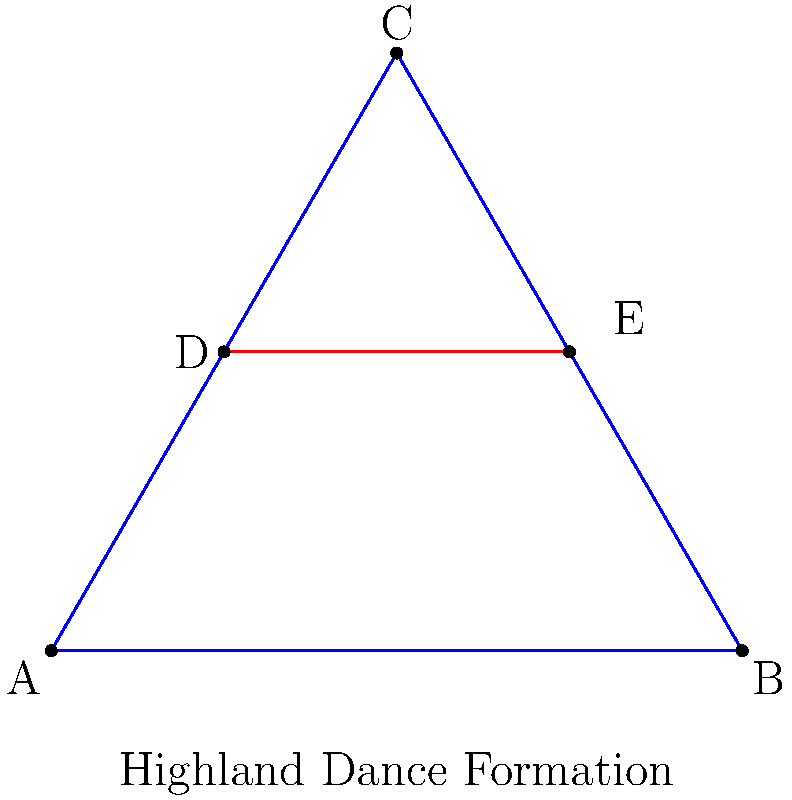In the Highland dance formation depicted above, dancers form an equilateral triangle ABC with a line segment DE connecting the midpoints of two sides. If the distance between dancers A and B is 8 feet, what is the length of DE in feet? Let's approach this step-by-step:

1) First, we recognize that ABC is an equilateral triangle, and DE is a line segment connecting the midpoints of two sides.

2) In an equilateral triangle, a line connecting the midpoints of two sides is parallel to the third side and half its length.

3) We're given that AB = 8 feet. Let's call the side length of the triangle $s$. So, $s = 8$ feet.

4) DE is parallel to AB and half its length. Therefore:

   $DE = \frac{1}{2}AB = \frac{1}{2} \cdot 8 = 4$ feet

5) We can verify this using the properties of similar triangles:
   - Triangle ABC is similar to triangle ADE
   - The ratio of their sides is 2:1
   - So if AB = 8, then DE = 4

Thus, the length of DE is 4 feet.
Answer: 4 feet 